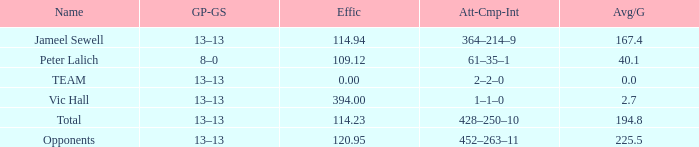What is the sum of the numbers for an average with a gp-gs ratio of 13-13 and an efficiency under 114.23? 1.0. Would you be able to parse every entry in this table? {'header': ['Name', 'GP-GS', 'Effic', 'Att-Cmp-Int', 'Avg/G'], 'rows': [['Jameel Sewell', '13–13', '114.94', '364–214–9', '167.4'], ['Peter Lalich', '8–0', '109.12', '61–35–1', '40.1'], ['TEAM', '13–13', '0.00', '2–2–0', '0.0'], ['Vic Hall', '13–13', '394.00', '1–1–0', '2.7'], ['Total', '13–13', '114.23', '428–250–10', '194.8'], ['Opponents', '13–13', '120.95', '452–263–11', '225.5']]} 